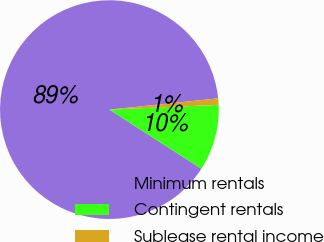Convert chart. <chart><loc_0><loc_0><loc_500><loc_500><pie_chart><fcel>Minimum rentals<fcel>Contingent rentals<fcel>Sublease rental income<nl><fcel>89.26%<fcel>9.79%<fcel>0.95%<nl></chart> 